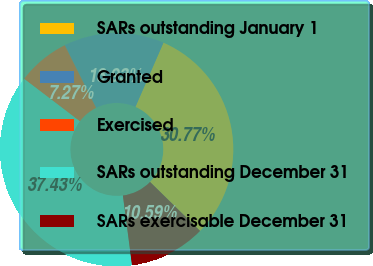Convert chart to OTSL. <chart><loc_0><loc_0><loc_500><loc_500><pie_chart><fcel>SARs outstanding January 1<fcel>Granted<fcel>Exercised<fcel>SARs outstanding December 31<fcel>SARs exercisable December 31<nl><fcel>30.77%<fcel>13.93%<fcel>7.27%<fcel>37.43%<fcel>10.59%<nl></chart> 